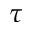<formula> <loc_0><loc_0><loc_500><loc_500>\tau</formula> 